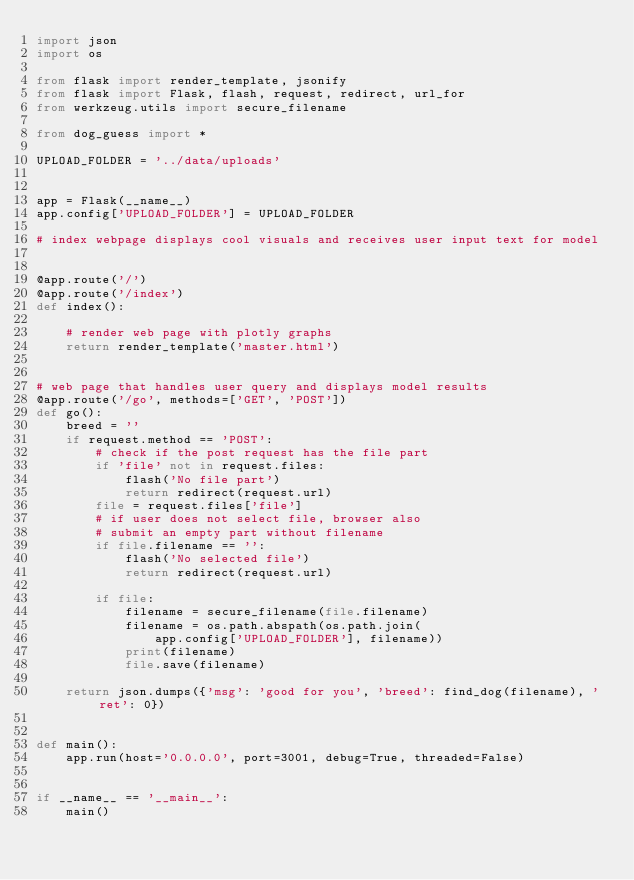Convert code to text. <code><loc_0><loc_0><loc_500><loc_500><_Python_>import json
import os

from flask import render_template, jsonify
from flask import Flask, flash, request, redirect, url_for
from werkzeug.utils import secure_filename

from dog_guess import *

UPLOAD_FOLDER = '../data/uploads'


app = Flask(__name__)
app.config['UPLOAD_FOLDER'] = UPLOAD_FOLDER

# index webpage displays cool visuals and receives user input text for model


@app.route('/')
@app.route('/index')
def index():

    # render web page with plotly graphs
    return render_template('master.html')


# web page that handles user query and displays model results
@app.route('/go', methods=['GET', 'POST'])
def go():
    breed = ''
    if request.method == 'POST':
        # check if the post request has the file part
        if 'file' not in request.files:
            flash('No file part')
            return redirect(request.url)
        file = request.files['file']
        # if user does not select file, browser also
        # submit an empty part without filename
        if file.filename == '':
            flash('No selected file')
            return redirect(request.url)

        if file:
            filename = secure_filename(file.filename)
            filename = os.path.abspath(os.path.join(
                app.config['UPLOAD_FOLDER'], filename))
            print(filename)
            file.save(filename)

    return json.dumps({'msg': 'good for you', 'breed': find_dog(filename), 'ret': 0})


def main():
    app.run(host='0.0.0.0', port=3001, debug=True, threaded=False)


if __name__ == '__main__':
    main()
</code> 